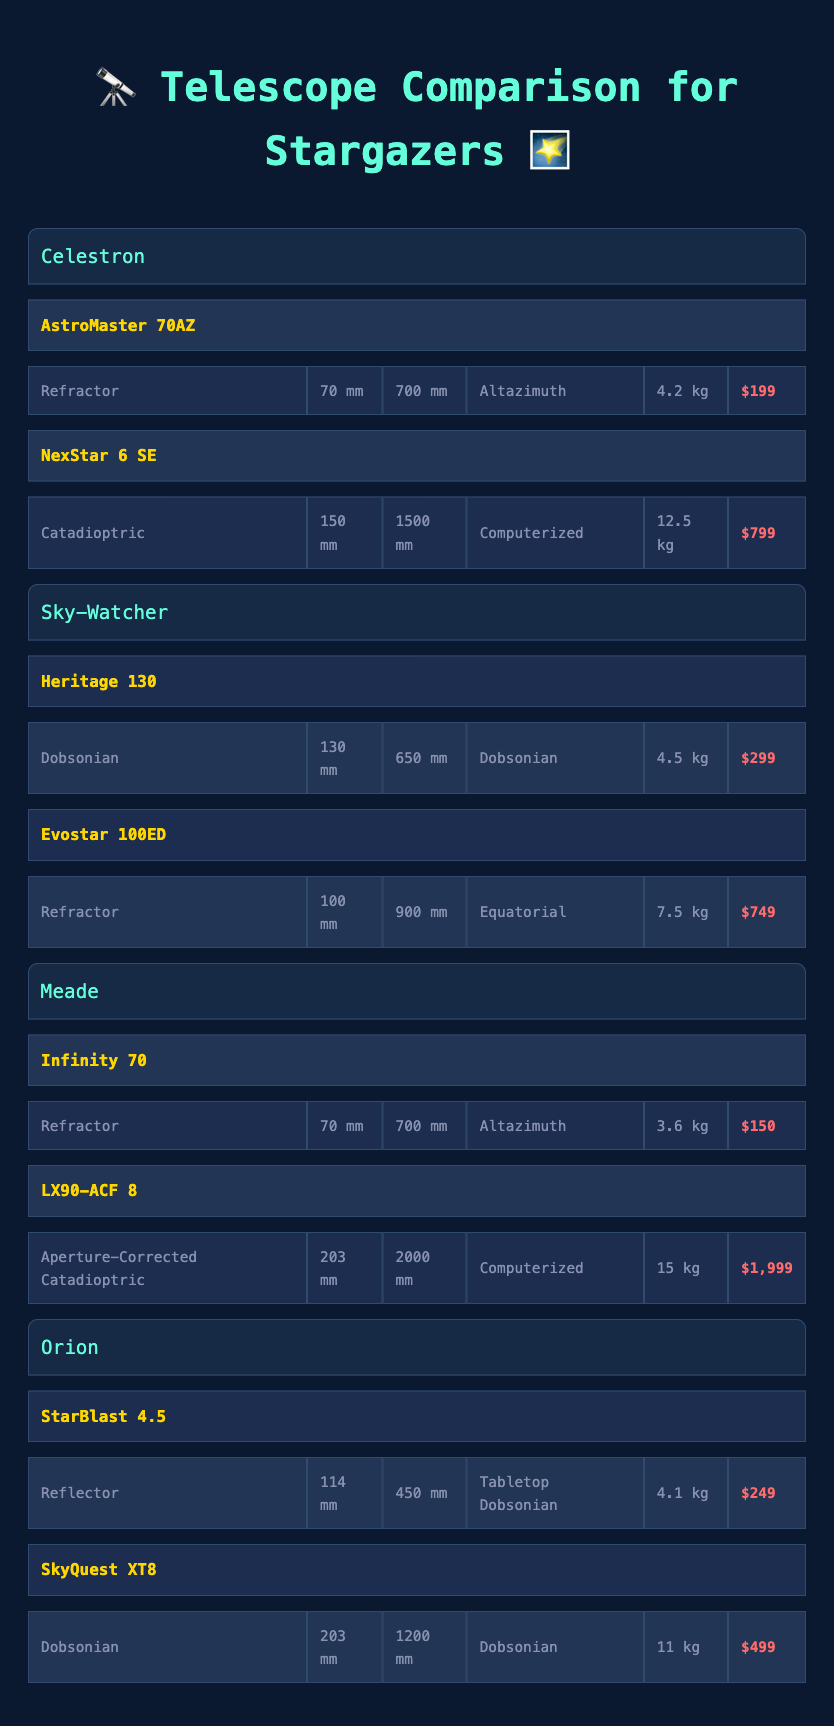What is the heaviest telescope in the table? The weight of each telescope is listed. The heaviest telescope is the LX90-ACF 8, which weighs 15 kg.
Answer: LX90-ACF 8 Which brand offers a refractor telescope with a 70 mm aperture at the lowest price? The table lists multiple 70 mm refractor telescopes by different brands. Meade's Infinity 70 is the lowest priced at $150.
Answer: Meade's Infinity 70 How many telescopes in the table are classified as Dobsonian? The table shows that there are two Dobsonian telescopes: the Heritage 130 from Sky-Watcher and the SkyQuest XT8 from Orion.
Answer: 2 What is the average aperture size of all telescopes in the table? The apertures of the telescopes are 70, 150, 130, 100, 70, 203, 114, and 203 mm. Summing them gives 70 + 150 + 130 + 100 + 70 + 203 + 114 + 203 = 1,040 mm. There are 8 telescopes, so the average is 1,040 / 8 = 130 mm.
Answer: 130 mm Is there a telescope from Orion that has a longer focal length than the NexStar 6 SE? The NexStar 6 SE has a focal length of 1500 mm. The SkyQuest XT8 from Orion has a focal length of 1200 mm, which is shorter, while the StarBlast 4.5 has a focal length of 450 mm. Therefore, there is no Orion telescope that exceeds the focal length of the NexStar 6 SE.
Answer: No Which telescopes have a computerized mount type, and what is their price range? The NexStar 6 SE and the LX90-ACF 8 both have a computerized mount type. Their prices are $799 and $1,999 respectively. This gives a price range of $799 to $1,999.
Answer: $799 to $1,999 How many telescopes have an aperture of 203 mm or larger? The table has two telescopes with an aperture of 203 mm or larger: the LX90-ACF 8 (203 mm) and the SkyQuest XT8 (203 mm). Thus, there are two telescopes that meet this criterion.
Answer: 2 What is the price difference between the cheapest and most expensive telescope in the table? The cheapest telescope is Meade's Infinity 70 at $150, and the most expensive is Meade's LX90-ACF 8 at $1,999. The price difference is $1,999 - $150 = $1,849.
Answer: $1,849 Which telescope has the shortest focal length and what type is it? The table shows that the StarBlast 4.5 has the shortest focal length at 450 mm. It is classified as a Reflector.
Answer: StarBlast 4.5, Reflector 